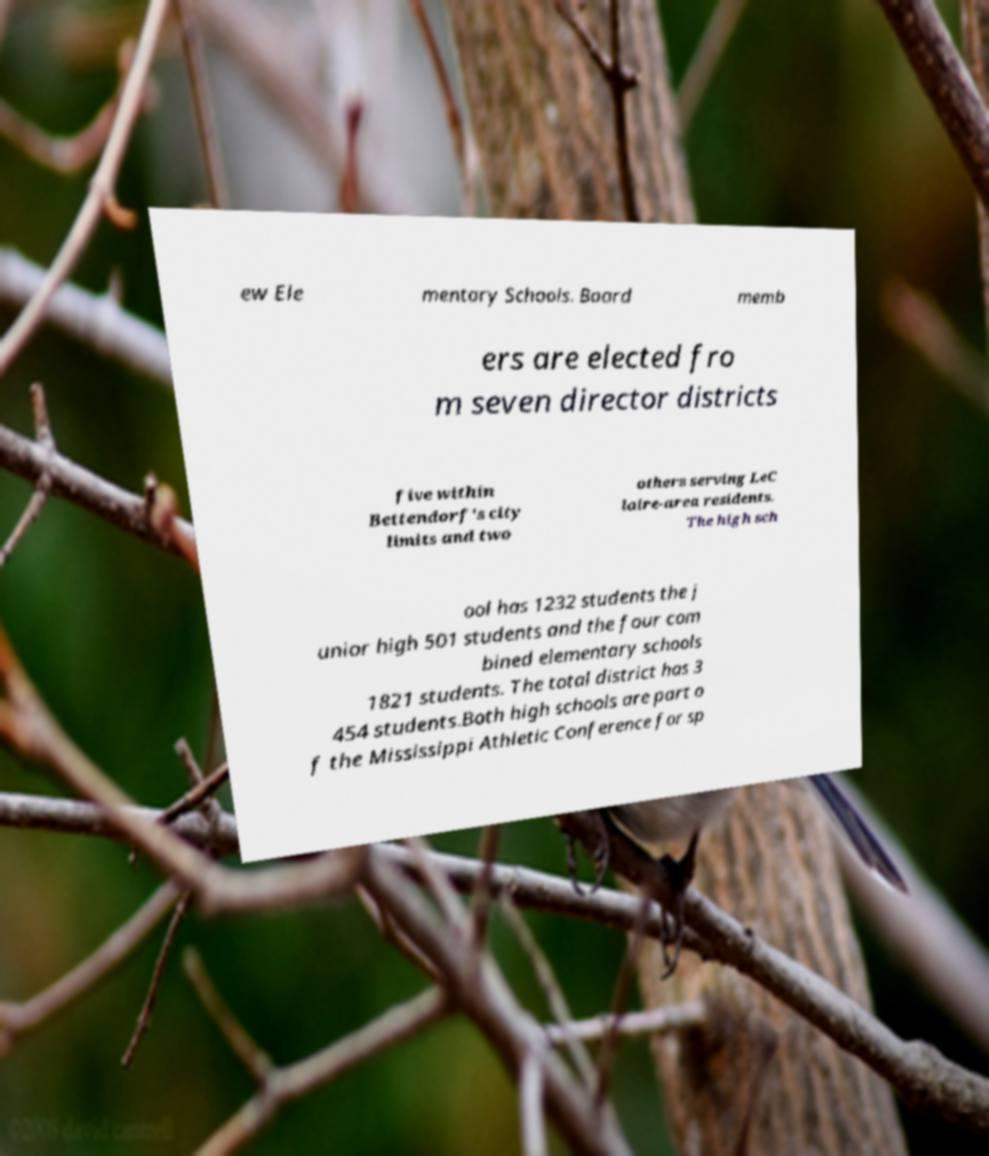Can you accurately transcribe the text from the provided image for me? ew Ele mentary Schools. Board memb ers are elected fro m seven director districts five within Bettendorf's city limits and two others serving LeC laire-area residents. The high sch ool has 1232 students the j unior high 501 students and the four com bined elementary schools 1821 students. The total district has 3 454 students.Both high schools are part o f the Mississippi Athletic Conference for sp 